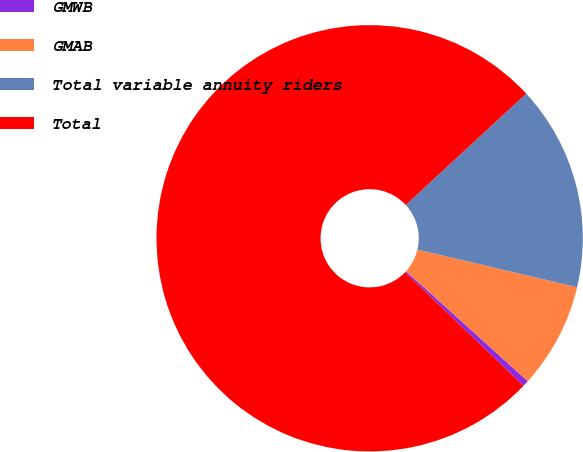<chart> <loc_0><loc_0><loc_500><loc_500><pie_chart><fcel>GMWB<fcel>GMAB<fcel>Total variable annuity riders<fcel>Total<nl><fcel>0.47%<fcel>8.01%<fcel>15.56%<fcel>75.96%<nl></chart> 